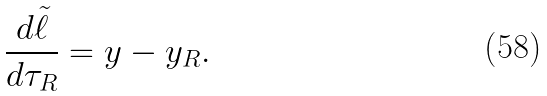Convert formula to latex. <formula><loc_0><loc_0><loc_500><loc_500>\frac { d \tilde { \ell } } { d \tau _ { R } } = y - y _ { R } .</formula> 